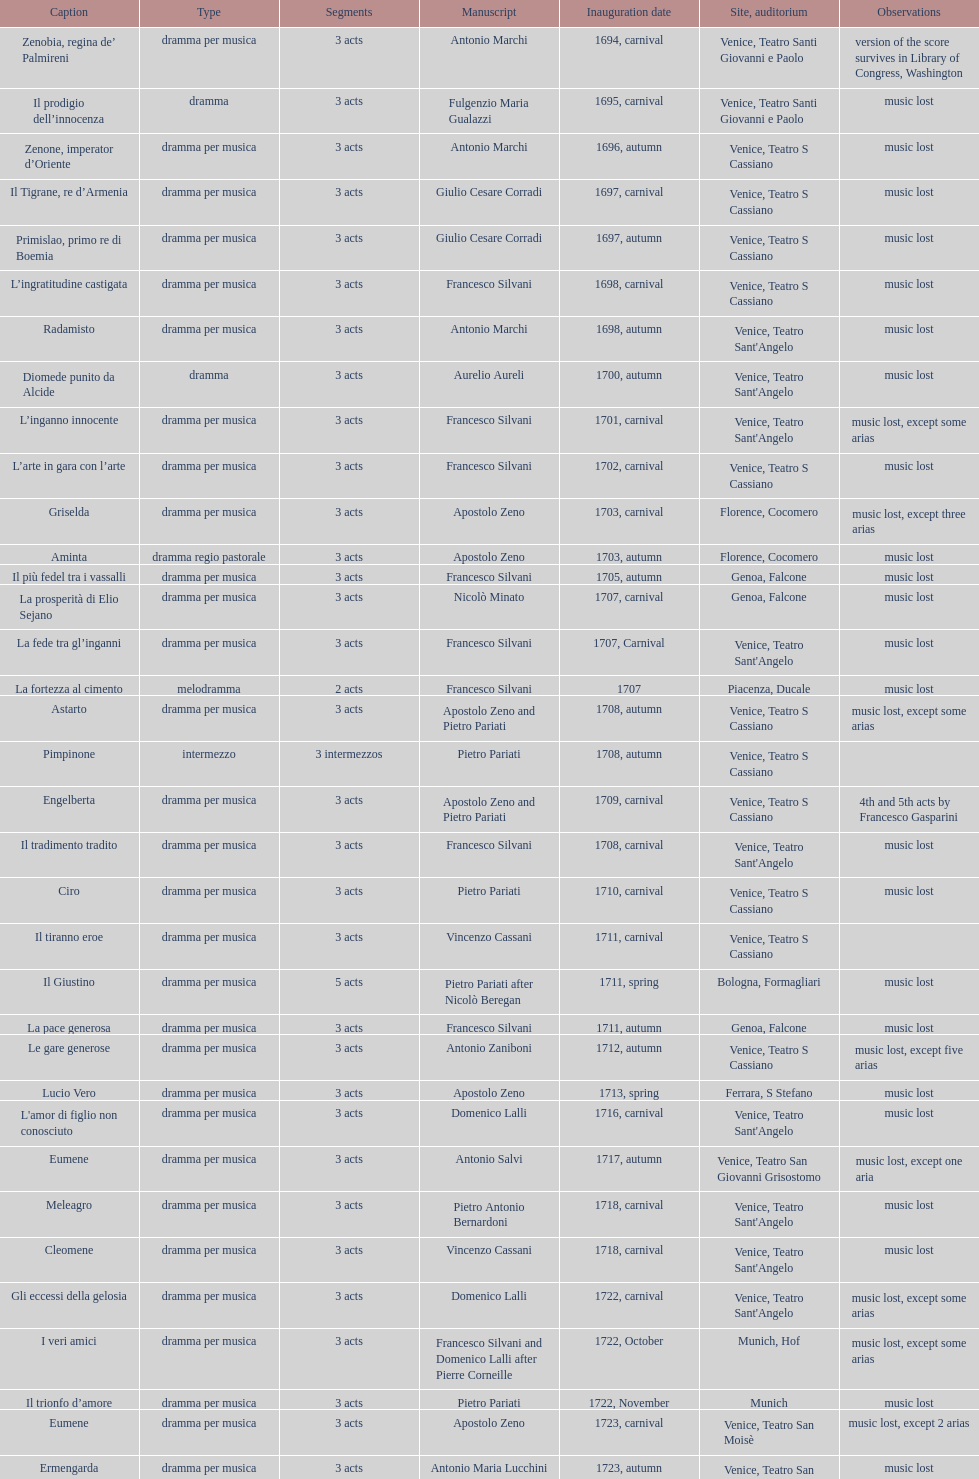How many were released after zenone, imperator d'oriente? 52. 